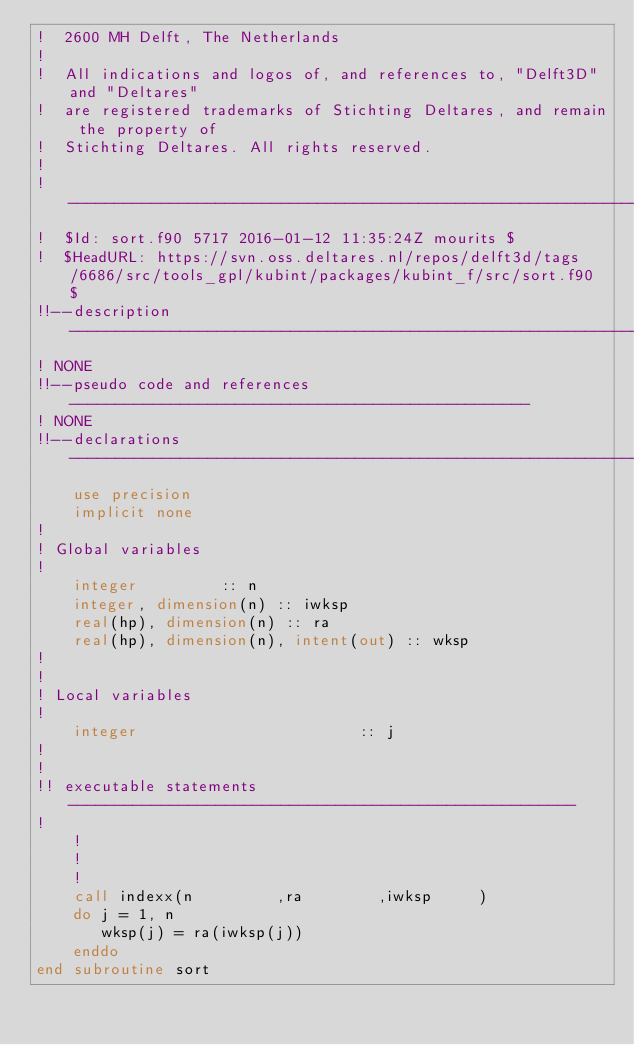Convert code to text. <code><loc_0><loc_0><loc_500><loc_500><_FORTRAN_>!  2600 MH Delft, The Netherlands                                               
!                                                                               
!  All indications and logos of, and references to, "Delft3D" and "Deltares"    
!  are registered trademarks of Stichting Deltares, and remain the property of  
!  Stichting Deltares. All rights reserved.                                     
!                                                                               
!-------------------------------------------------------------------------------
!  $Id: sort.f90 5717 2016-01-12 11:35:24Z mourits $
!  $HeadURL: https://svn.oss.deltares.nl/repos/delft3d/tags/6686/src/tools_gpl/kubint/packages/kubint_f/src/sort.f90 $
!!--description-----------------------------------------------------------------
! NONE
!!--pseudo code and references--------------------------------------------------
! NONE
!!--declarations----------------------------------------------------------------
    use precision
    implicit none
!
! Global variables
!
    integer         :: n
    integer, dimension(n) :: iwksp
    real(hp), dimension(n) :: ra
    real(hp), dimension(n), intent(out) :: wksp
!
!
! Local variables
!
    integer                        :: j
!
!
!! executable statements -------------------------------------------------------
!
    !
    !
    !
    call indexx(n         ,ra        ,iwksp     )
    do j = 1, n
       wksp(j) = ra(iwksp(j))
    enddo
end subroutine sort
</code> 